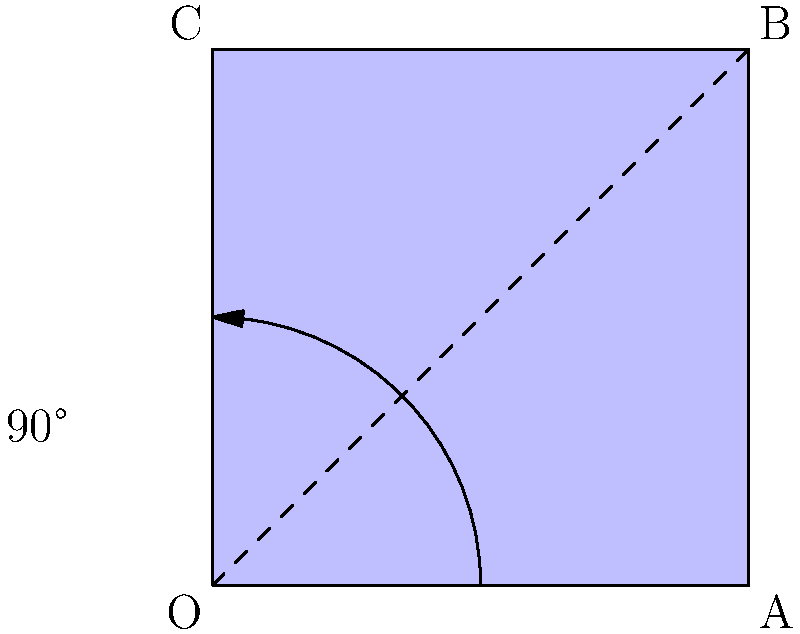A book cover design for a poetry anthology is represented by the blue rectangle OABC. The publisher wants to rotate the design 90° counterclockwise around point O to create a visually striking effect for a special edition. What will be the coordinates of point A after this rotation? To solve this problem, we'll follow these steps:

1) First, let's identify the initial coordinates:
   O: (0, 0)
   A: (2, 0)

2) When rotating a point 90° counterclockwise around the origin, we use the following transformation:
   $$(x, y) \rightarrow (-y, x)$$

3) Applying this to point A (2, 0):
   x = 2, y = 0
   New coordinates: (-0, 2)

4) Simplifying:
   The new coordinates of A after rotation will be (0, 2)

This rotation effectively moves point A to where point C was originally, which aligns with our visual intuition of a 90° counterclockwise rotation.
Answer: (0, 2) 